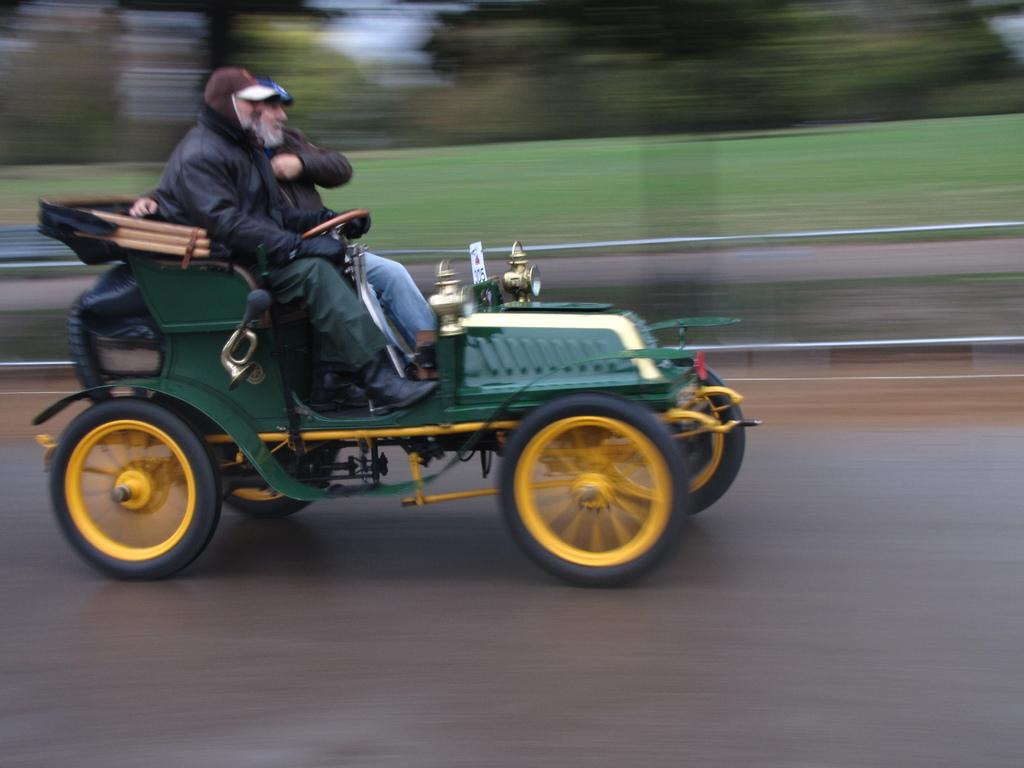How many people are in the image? There are two men in the image. What are the men doing in the image? The men are moving on a car. Where is the car located in the image? The car is on the road. What color is the pig in the image? There is no pig present in the image. How many socks are visible on the men in the image? There is no mention of socks in the image, so we cannot determine the number of socks visible. 